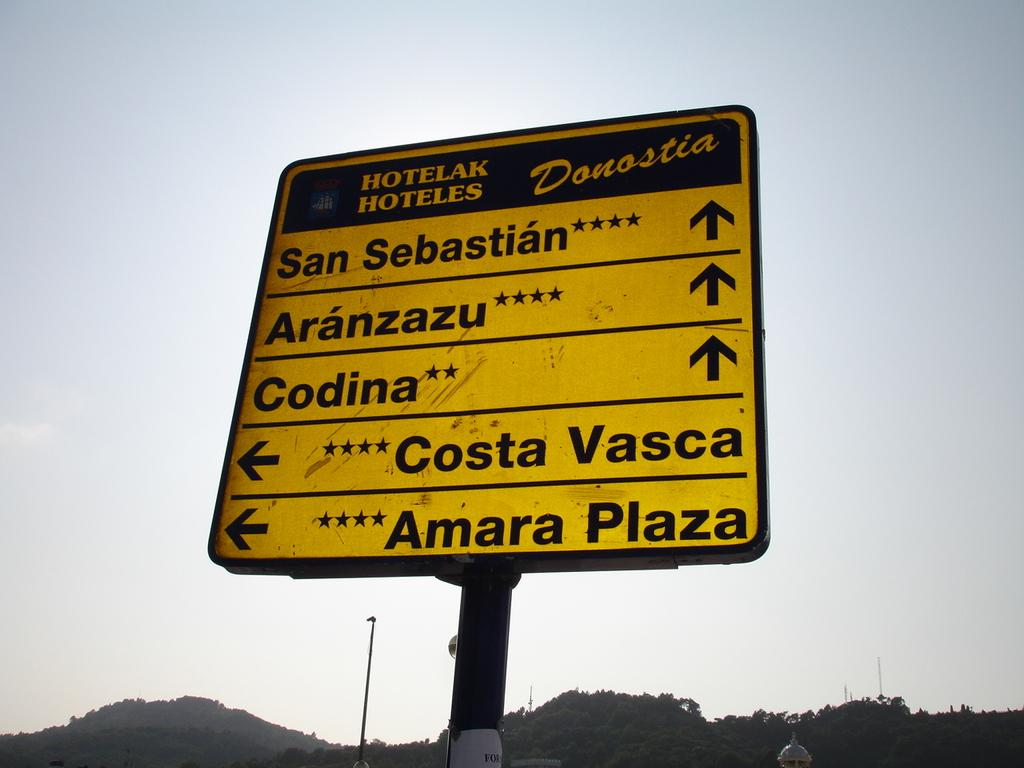<image>
Offer a succinct explanation of the picture presented. A sign that says Donostia points to different places. 